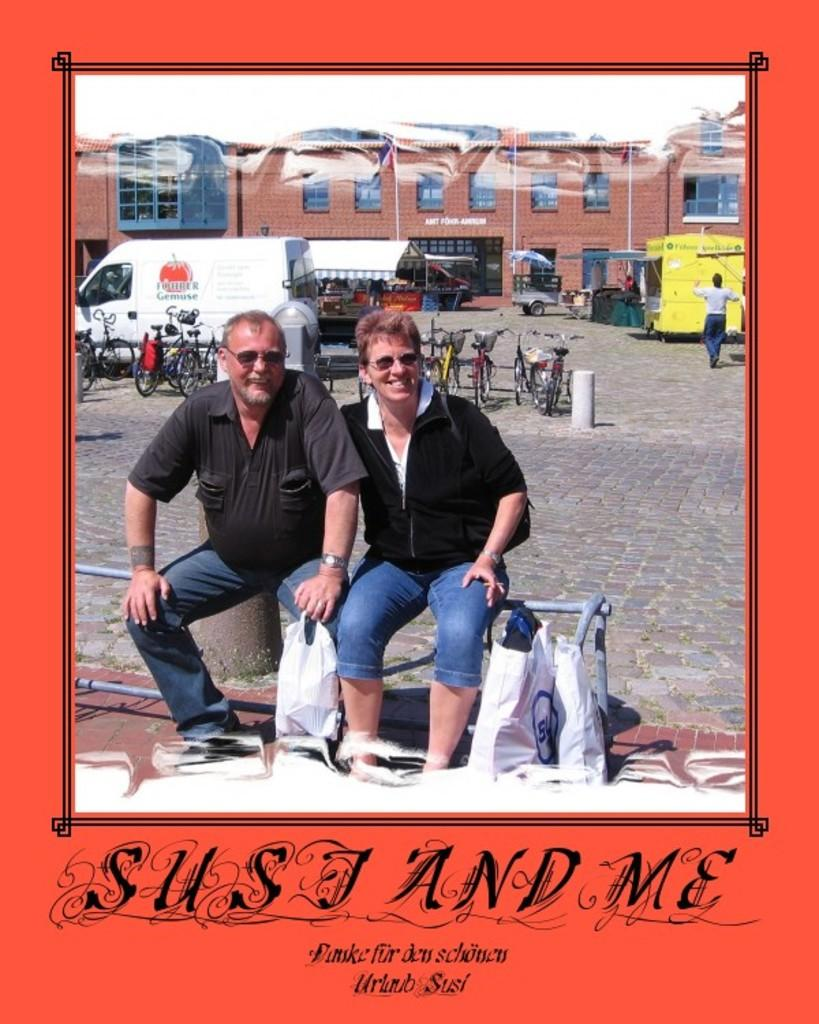<image>
Create a compact narrative representing the image presented. A photograph of two people over the caption Susi and me. 